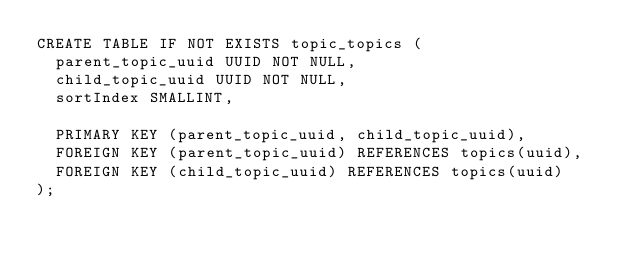<code> <loc_0><loc_0><loc_500><loc_500><_SQL_>CREATE TABLE IF NOT EXISTS topic_topics (
  parent_topic_uuid UUID NOT NULL,
  child_topic_uuid UUID NOT NULL,
  sortIndex SMALLINT,

  PRIMARY KEY (parent_topic_uuid, child_topic_uuid),
  FOREIGN KEY (parent_topic_uuid) REFERENCES topics(uuid),
  FOREIGN KEY (child_topic_uuid) REFERENCES topics(uuid)
);
</code> 